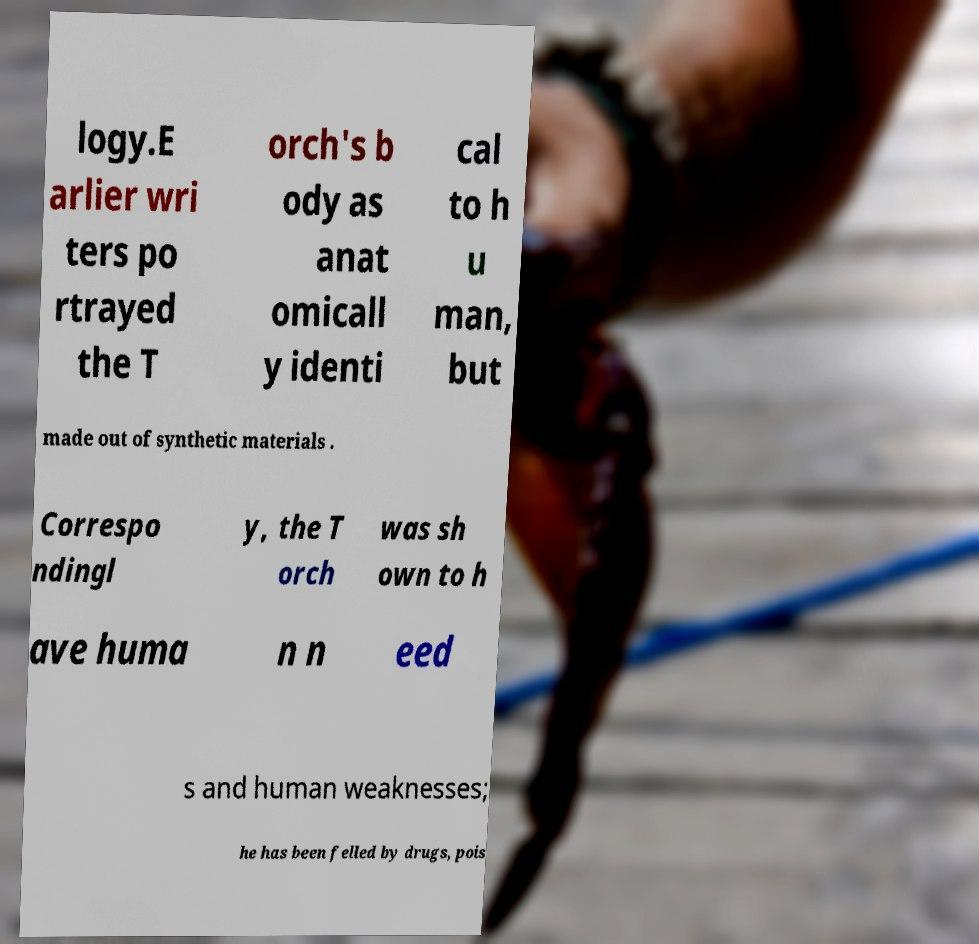There's text embedded in this image that I need extracted. Can you transcribe it verbatim? logy.E arlier wri ters po rtrayed the T orch's b ody as anat omicall y identi cal to h u man, but made out of synthetic materials . Correspo ndingl y, the T orch was sh own to h ave huma n n eed s and human weaknesses; he has been felled by drugs, pois 